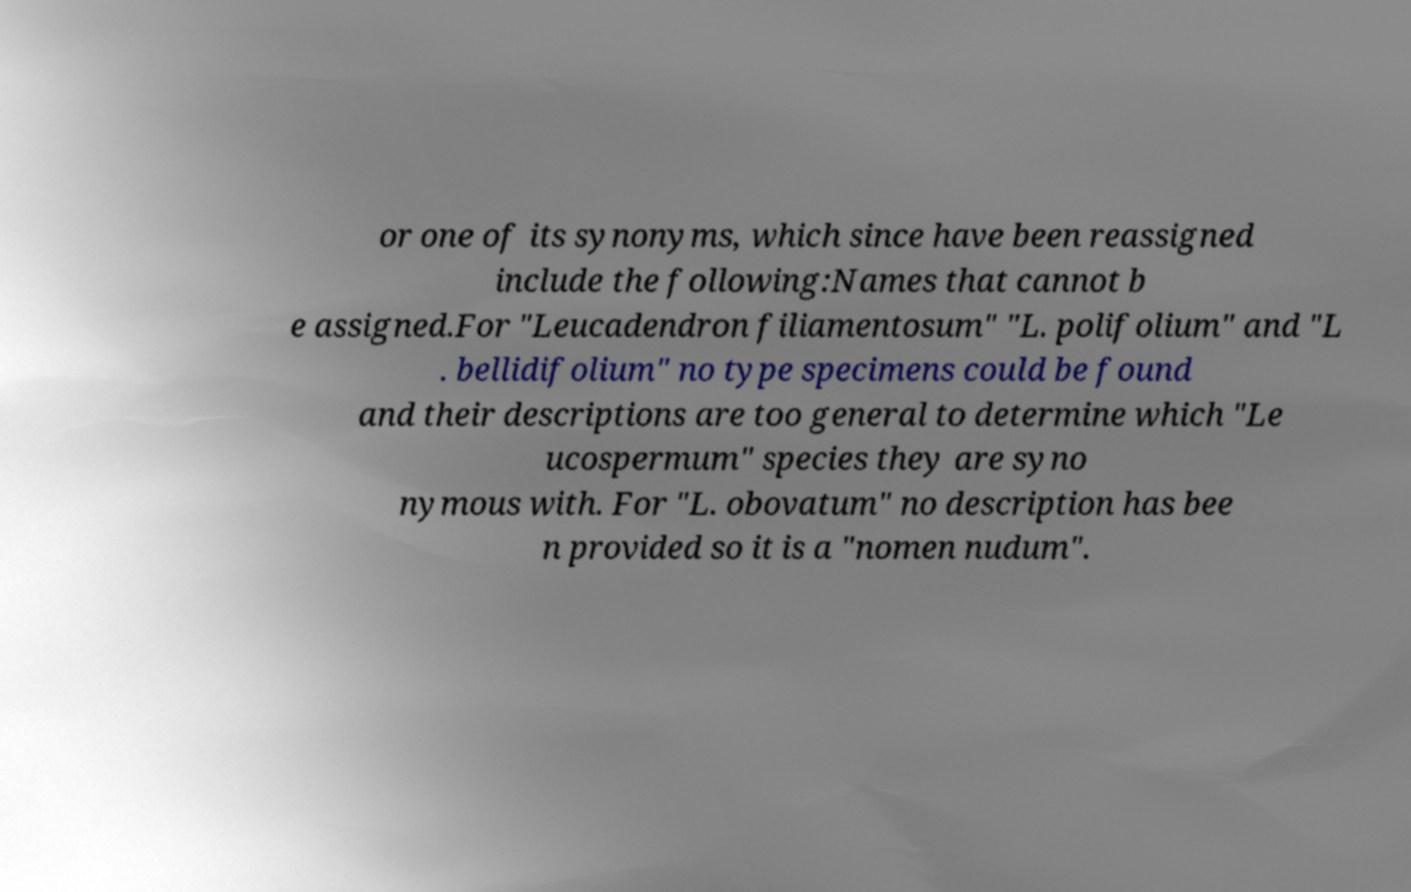I need the written content from this picture converted into text. Can you do that? or one of its synonyms, which since have been reassigned include the following:Names that cannot b e assigned.For "Leucadendron filiamentosum" "L. polifolium" and "L . bellidifolium" no type specimens could be found and their descriptions are too general to determine which "Le ucospermum" species they are syno nymous with. For "L. obovatum" no description has bee n provided so it is a "nomen nudum". 